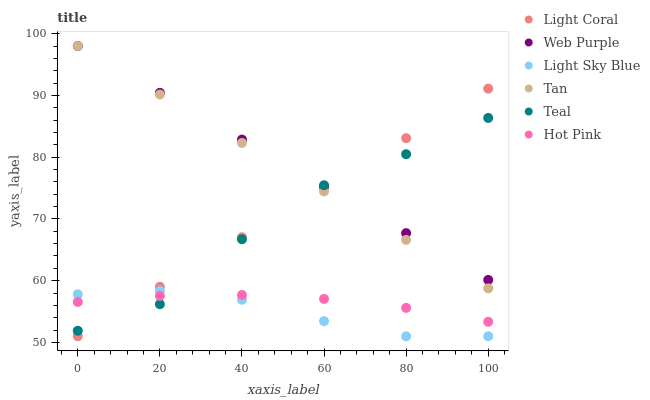Does Light Sky Blue have the minimum area under the curve?
Answer yes or no. Yes. Does Web Purple have the maximum area under the curve?
Answer yes or no. Yes. Does Light Coral have the minimum area under the curve?
Answer yes or no. No. Does Light Coral have the maximum area under the curve?
Answer yes or no. No. Is Light Coral the smoothest?
Answer yes or no. Yes. Is Teal the roughest?
Answer yes or no. Yes. Is Web Purple the smoothest?
Answer yes or no. No. Is Web Purple the roughest?
Answer yes or no. No. Does Light Coral have the lowest value?
Answer yes or no. Yes. Does Web Purple have the lowest value?
Answer yes or no. No. Does Tan have the highest value?
Answer yes or no. Yes. Does Light Coral have the highest value?
Answer yes or no. No. Is Light Sky Blue less than Web Purple?
Answer yes or no. Yes. Is Web Purple greater than Light Sky Blue?
Answer yes or no. Yes. Does Light Sky Blue intersect Light Coral?
Answer yes or no. Yes. Is Light Sky Blue less than Light Coral?
Answer yes or no. No. Is Light Sky Blue greater than Light Coral?
Answer yes or no. No. Does Light Sky Blue intersect Web Purple?
Answer yes or no. No. 